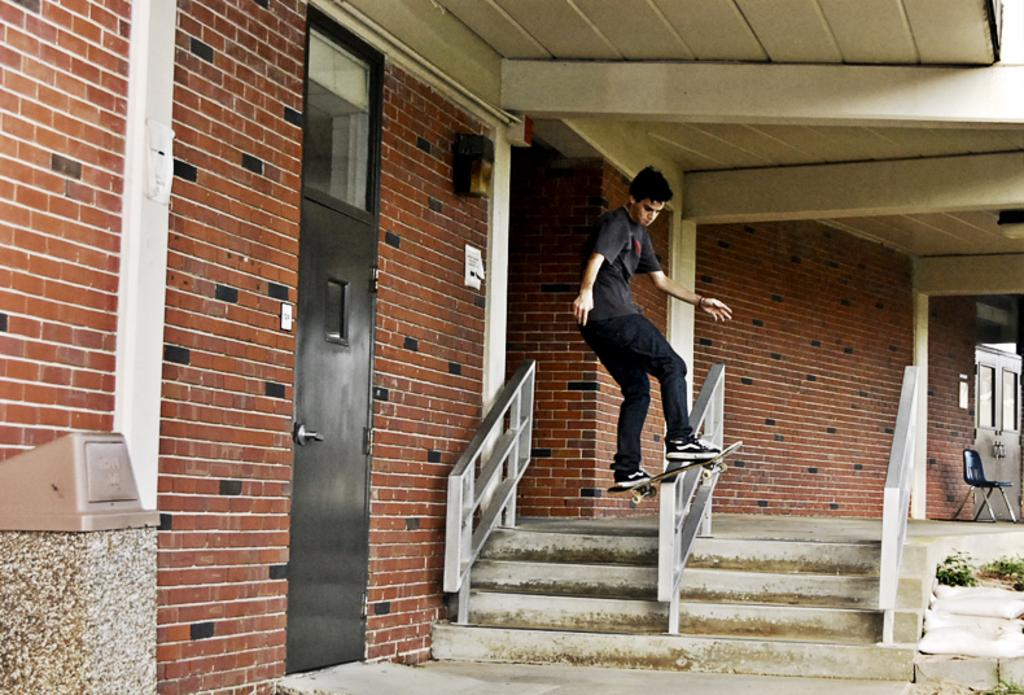What is the main subject of the image? There is a person in the image. What is the person wearing? The person is wearing a black dress. What activity is the person engaged in? The person is skating on fencing using a skateboard. What architectural feature can be seen in the image? There are stairs visible in the image. What is located on the left side of the image? There is a brick wall on the left side of the image. How does the person become an expert in skating on fencing using a skateboard in the image? The image does not show the person becoming an expert or provide any information about their skill level. --- Facts: 1. There is a person in the image. 2. The person is holding a book. 3. The person is sitting on a bench. 4. There is a tree in the background of the image. 5. The sky is visible in the image. Absurd Topics: parrot, sand, umbrella Conversation: What is the main subject of the image? There is a person in the image. What is the person holding? The person is holding a book. Where is the person sitting? The person is sitting on a bench. What can be seen in the background of the image? There is a tree in the background of the image. What is visible at the top of the image? The sky is visible in the image. Reasoning: Let's think step by step in order to produce the conversation. We start by identifying the main subject of the image, which is the person. Then, we describe the object the person is holding (a book) and the location where they are sitting (on a bench). Next, we mention the background element (a tree) and the sky visible at the top of the image. Each question is designed to elicit a specific detail about the image that is known from the provided facts. Absurd Question/Answer: Can you tell me how many parrots are sitting on the bench with the person in the image? There are no parrots present in the image; only the person and a book are visible. 